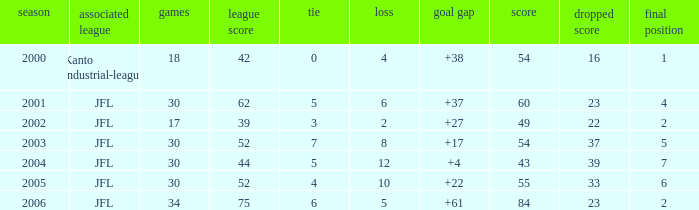I'm looking to parse the entire table for insights. Could you assist me with that? {'header': ['season', 'associated league', 'games', 'league score', 'tie', 'loss', 'goal gap', 'score', 'dropped score', 'final position'], 'rows': [['2000', 'Kanto industrial-league', '18', '42', '0', '4', '+38', '54', '16', '1'], ['2001', 'JFL', '30', '62', '5', '6', '+37', '60', '23', '4'], ['2002', 'JFL', '17', '39', '3', '2', '+27', '49', '22', '2'], ['2003', 'JFL', '30', '52', '7', '8', '+17', '54', '37', '5'], ['2004', 'JFL', '30', '44', '5', '12', '+4', '43', '39', '7'], ['2005', 'JFL', '30', '52', '4', '10', '+22', '55', '33', '6'], ['2006', 'JFL', '34', '75', '6', '5', '+61', '84', '23', '2']]} I want the total number of matches for draw less than 7 and lost point of 16 with lose more than 4 0.0. 